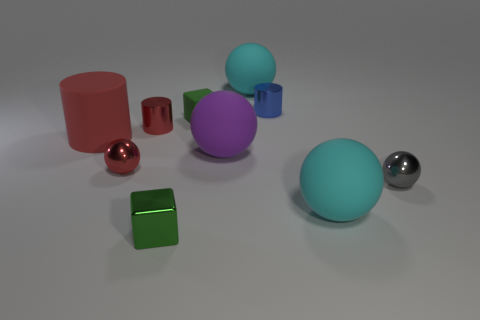Can you describe the shapes and their colors in this image? Certainly! The image shows a collection of 3D-rendered shapes. There's a large red vertical cylinder, a small crimson horizontal cylinder, a purple sphere, a teal sphere, a small blue cube, a green rectangular prism, and a shiny silver sphere. The background is neutral, with a subtle shadow under each object on what appears to be a gray floor. 